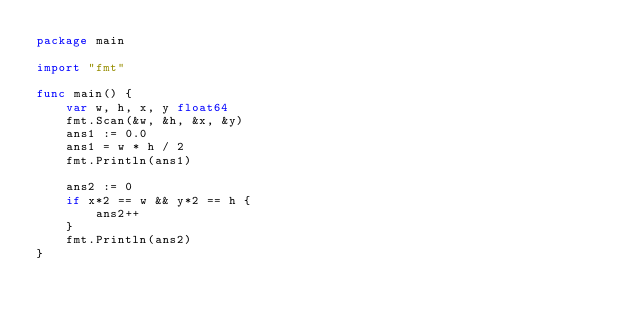Convert code to text. <code><loc_0><loc_0><loc_500><loc_500><_Go_>package main

import "fmt"

func main() {
	var w, h, x, y float64
	fmt.Scan(&w, &h, &x, &y)
	ans1 := 0.0
	ans1 = w * h / 2
	fmt.Println(ans1)

	ans2 := 0
	if x*2 == w && y*2 == h {
		ans2++
	}
	fmt.Println(ans2)
}
</code> 